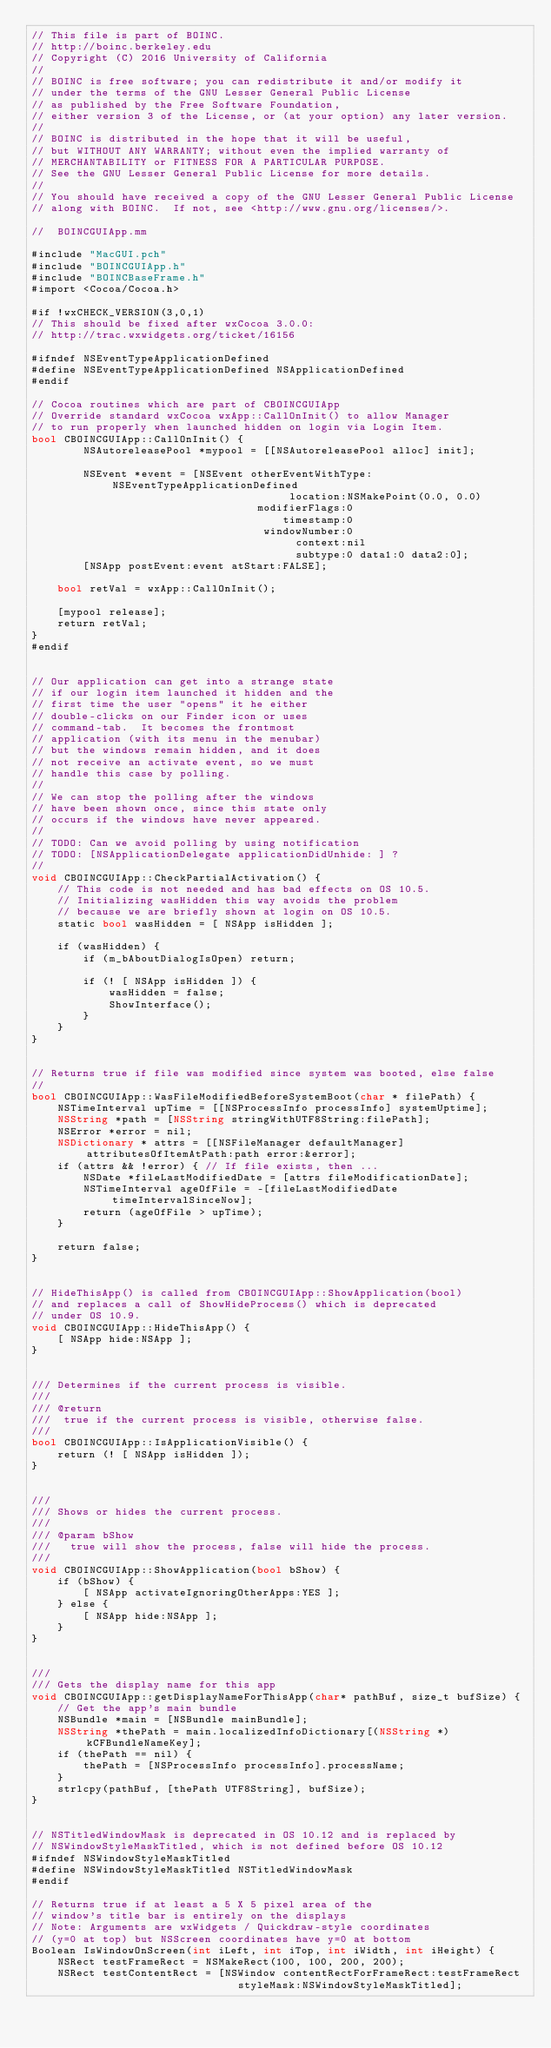Convert code to text. <code><loc_0><loc_0><loc_500><loc_500><_ObjectiveC_>// This file is part of BOINC.
// http://boinc.berkeley.edu
// Copyright (C) 2016 University of California
//
// BOINC is free software; you can redistribute it and/or modify it
// under the terms of the GNU Lesser General Public License
// as published by the Free Software Foundation,
// either version 3 of the License, or (at your option) any later version.
//
// BOINC is distributed in the hope that it will be useful,
// but WITHOUT ANY WARRANTY; without even the implied warranty of
// MERCHANTABILITY or FITNESS FOR A PARTICULAR PURPOSE.
// See the GNU Lesser General Public License for more details.
//
// You should have received a copy of the GNU Lesser General Public License
// along with BOINC.  If not, see <http://www.gnu.org/licenses/>.

//  BOINCGUIApp.mm

#include "MacGUI.pch"
#include "BOINCGUIApp.h"
#include "BOINCBaseFrame.h"
#import <Cocoa/Cocoa.h>

#if !wxCHECK_VERSION(3,0,1)
// This should be fixed after wxCocoa 3.0.0:
// http://trac.wxwidgets.org/ticket/16156

#ifndef NSEventTypeApplicationDefined
#define NSEventTypeApplicationDefined NSApplicationDefined
#endif

// Cocoa routines which are part of CBOINCGUIApp
// Override standard wxCocoa wxApp::CallOnInit() to allow Manager
// to run properly when launched hidden on login via Login Item. 
bool CBOINCGUIApp::CallOnInit() {
        NSAutoreleasePool *mypool = [[NSAutoreleasePool alloc] init];

        NSEvent *event = [NSEvent otherEventWithType:NSEventTypeApplicationDefined
                                        location:NSMakePoint(0.0, 0.0) 
                                   modifierFlags:0 
                                       timestamp:0 
                                    windowNumber:0 
                                         context:nil
                                         subtype:0 data1:0 data2:0]; 
        [NSApp postEvent:event atStart:FALSE];

    bool retVal = wxApp::CallOnInit();

    [mypool release];
    return retVal;
}
#endif


// Our application can get into a strange state 
// if our login item launched it hidden and the
// first time the user "opens" it he either
// double-clicks on our Finder icon or uses
// command-tab.  It becomes the frontmost
// application (with its menu in the menubar)
// but the windows remain hidden, and it does
// not receive an activate event, so we must 
// handle this case by polling.
//
// We can stop the polling after the windows
// have been shown once, since this state only
// occurs if the windows have never appeared.
//
// TODO: Can we avoid polling by using notification
// TODO: [NSApplicationDelegate applicationDidUnhide: ] ?
//
void CBOINCGUIApp::CheckPartialActivation() {
    // This code is not needed and has bad effects on OS 10.5.
    // Initializing wasHidden this way avoids the problem 
    // because we are briefly shown at login on OS 10.5.
    static bool wasHidden = [ NSApp isHidden ];
    
    if (wasHidden) {
        if (m_bAboutDialogIsOpen) return;
        
        if (! [ NSApp isHidden ]) {
            wasHidden = false;
            ShowInterface();
        }
    }
}


// Returns true if file was modified since system was booted, else false
//
bool CBOINCGUIApp::WasFileModifiedBeforeSystemBoot(char * filePath) {
    NSTimeInterval upTime = [[NSProcessInfo processInfo] systemUptime];
    NSString *path = [NSString stringWithUTF8String:filePath];
    NSError *error = nil;
    NSDictionary * attrs = [[NSFileManager defaultManager] attributesOfItemAtPath:path error:&error];
    if (attrs && !error) { // If file exists, then ...
        NSDate *fileLastModifiedDate = [attrs fileModificationDate];
        NSTimeInterval ageOfFile = -[fileLastModifiedDate timeIntervalSinceNow];
        return (ageOfFile > upTime);
    }
    
    return false;
}


// HideThisApp() is called from CBOINCGUIApp::ShowApplication(bool)
// and replaces a call of ShowHideProcess() which is deprecated
// under OS 10.9.
void CBOINCGUIApp::HideThisApp() {
    [ NSApp hide:NSApp ];
}


/// Determines if the current process is visible.
///
/// @return
///  true if the current process is visible, otherwise false.
/// 
bool CBOINCGUIApp::IsApplicationVisible() {
    return (! [ NSApp isHidden ]);
}


///
/// Shows or hides the current process.
///
/// @param bShow
///   true will show the process, false will hide the process.
///
void CBOINCGUIApp::ShowApplication(bool bShow) {
    if (bShow) {
        [ NSApp activateIgnoringOtherApps:YES ];
    } else {
        [ NSApp hide:NSApp ];
    }
}


///
/// Gets the display name for this app
void CBOINCGUIApp::getDisplayNameForThisApp(char* pathBuf, size_t bufSize) {
    // Get the app's main bundle
    NSBundle *main = [NSBundle mainBundle];
    NSString *thePath = main.localizedInfoDictionary[(NSString *)kCFBundleNameKey];
    if (thePath == nil) {
        thePath = [NSProcessInfo processInfo].processName;
    }
    strlcpy(pathBuf, [thePath UTF8String], bufSize);
}


// NSTitledWindowMask is deprecated in OS 10.12 and is replaced by
// NSWindowStyleMaskTitled, which is not defined before OS 10.12
#ifndef NSWindowStyleMaskTitled
#define NSWindowStyleMaskTitled NSTitledWindowMask
#endif

// Returns true if at least a 5 X 5 pixel area of the 
// window's title bar is entirely on the displays
// Note: Arguments are wxWidgets / Quickdraw-style coordinates
// (y=0 at top) but NSScreen coordinates have y=0 at bottom
Boolean IsWindowOnScreen(int iLeft, int iTop, int iWidth, int iHeight) {
    NSRect testFrameRect = NSMakeRect(100, 100, 200, 200);
    NSRect testContentRect = [NSWindow contentRectForFrameRect:testFrameRect
                                styleMask:NSWindowStyleMaskTitled];</code> 